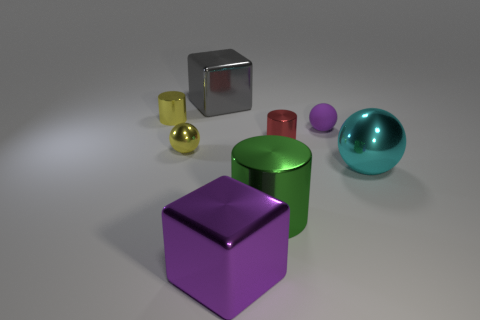There is a tiny yellow object that is the same shape as the red thing; what is its material?
Offer a terse response. Metal. Are the large cyan sphere and the small purple thing made of the same material?
Your response must be concise. No. Is the shape of the tiny shiny thing that is on the right side of the purple metal object the same as the large metal thing on the left side of the purple metal cube?
Your answer should be very brief. No. Are there any big cylinders that have the same material as the gray thing?
Provide a short and direct response. Yes. The matte sphere is what color?
Make the answer very short. Purple. There is a yellow metal object that is in front of the tiny red cylinder; how big is it?
Offer a terse response. Small. How many big objects have the same color as the small matte ball?
Your response must be concise. 1. There is a big metal block that is in front of the green cylinder; are there any metal spheres left of it?
Offer a terse response. Yes. Do the tiny sphere that is left of the matte sphere and the tiny shiny cylinder left of the big green cylinder have the same color?
Provide a short and direct response. Yes. There is another cylinder that is the same size as the red cylinder; what color is it?
Your answer should be compact. Yellow. 